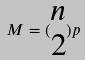Convert formula to latex. <formula><loc_0><loc_0><loc_500><loc_500>M = ( \begin{matrix} n \\ 2 \end{matrix} ) p</formula> 